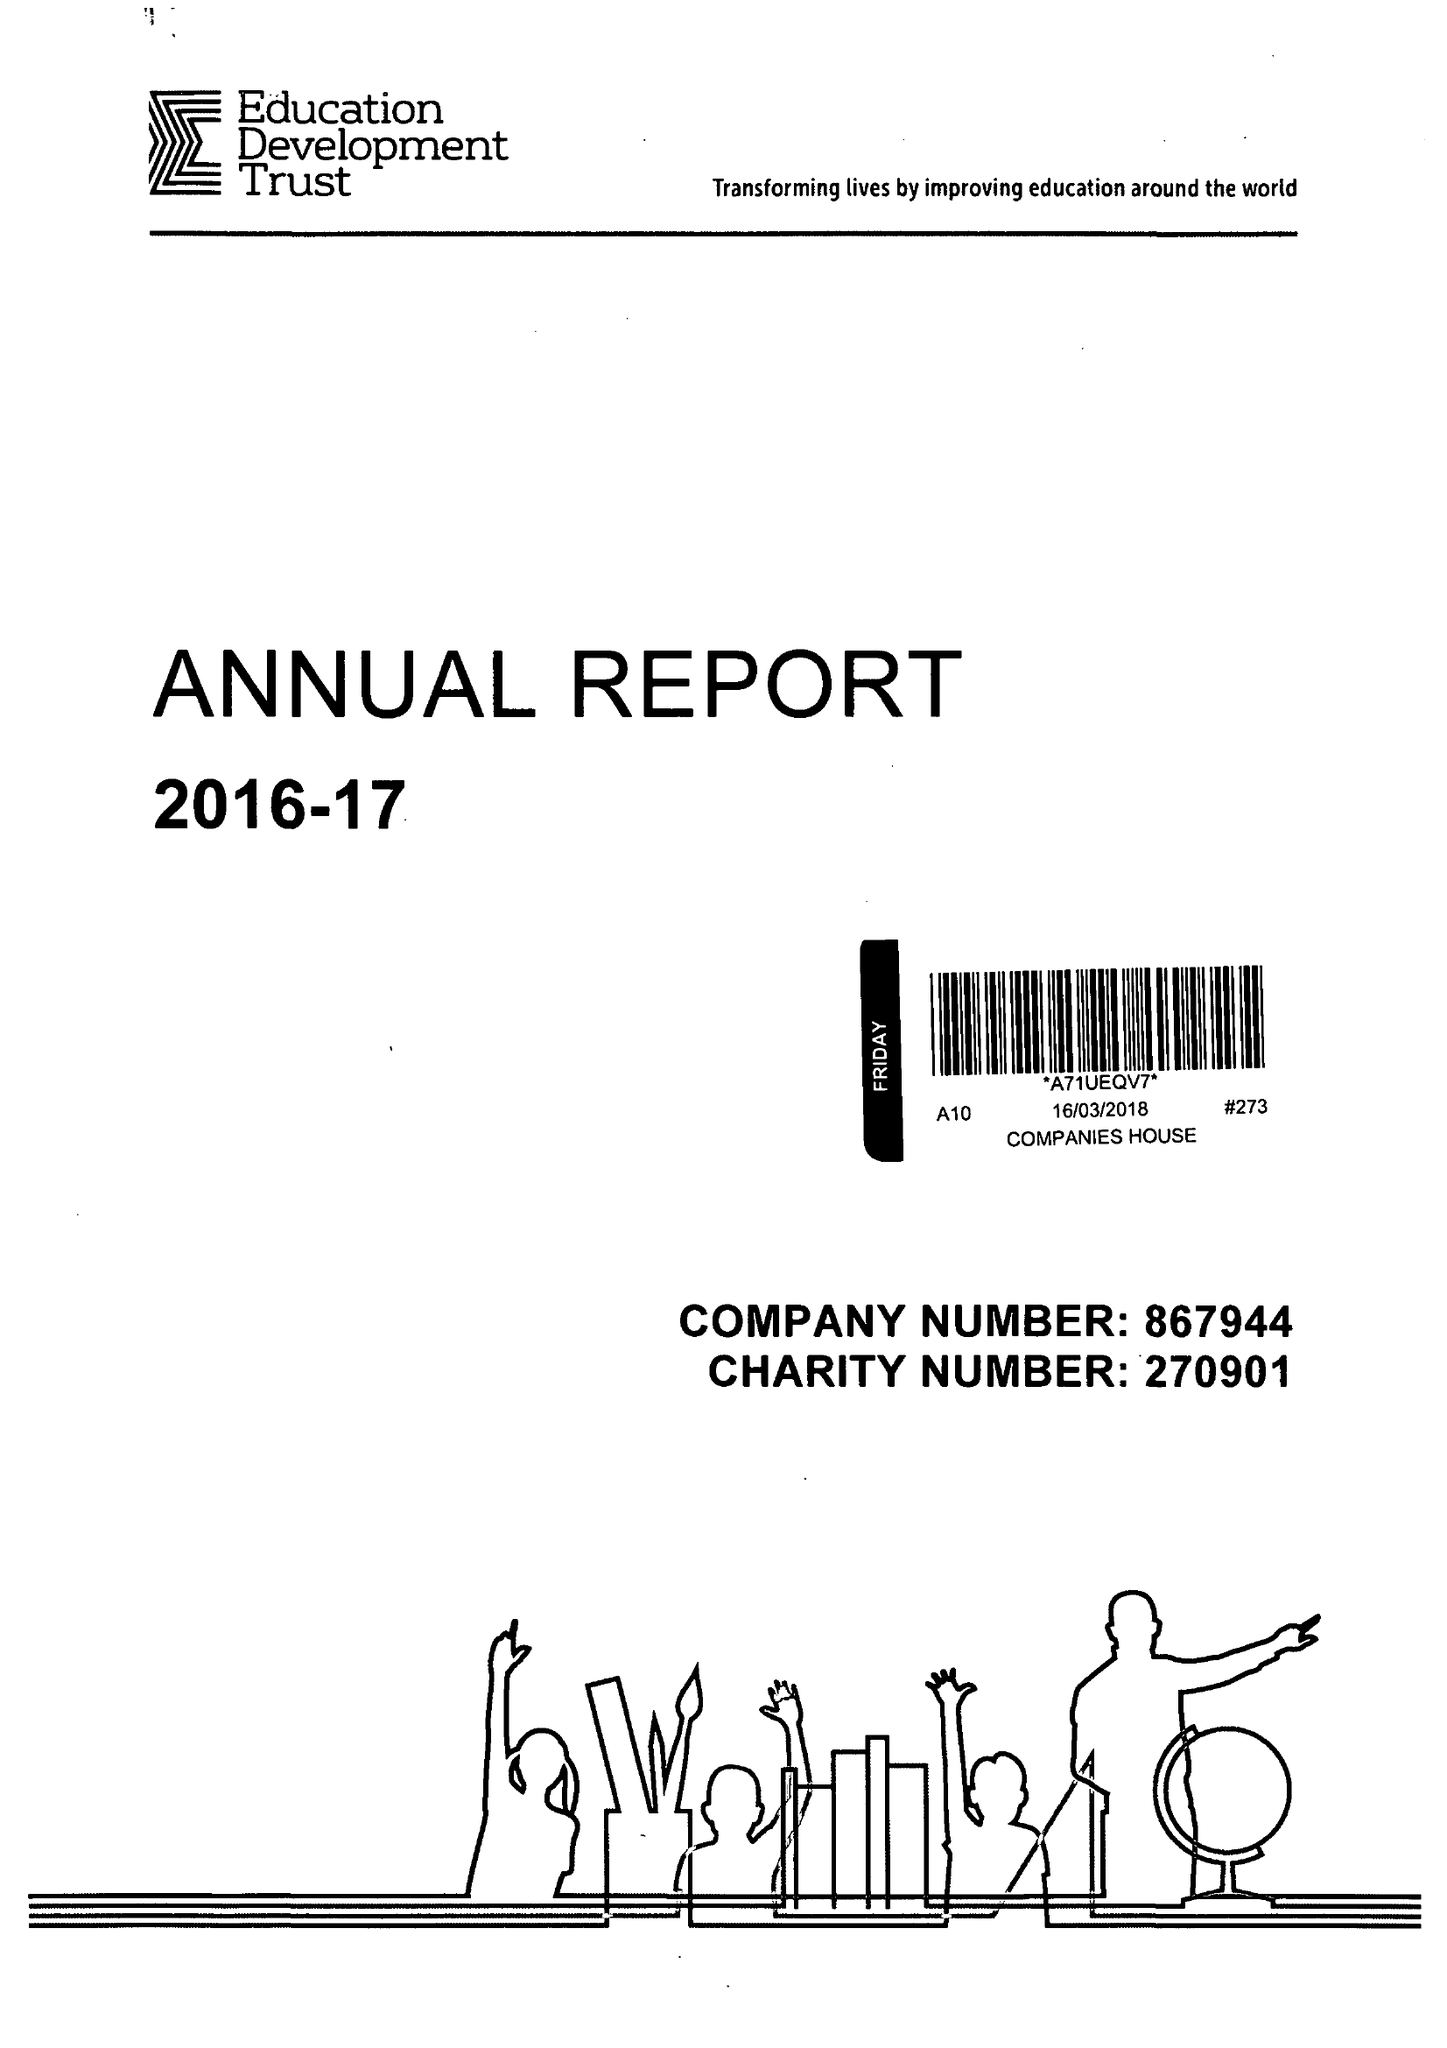What is the value for the address__post_town?
Answer the question using a single word or phrase. READING 